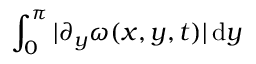<formula> <loc_0><loc_0><loc_500><loc_500>\int _ { 0 } ^ { \pi } | \partial _ { y } \omega ( x , y , t ) | \, d y</formula> 